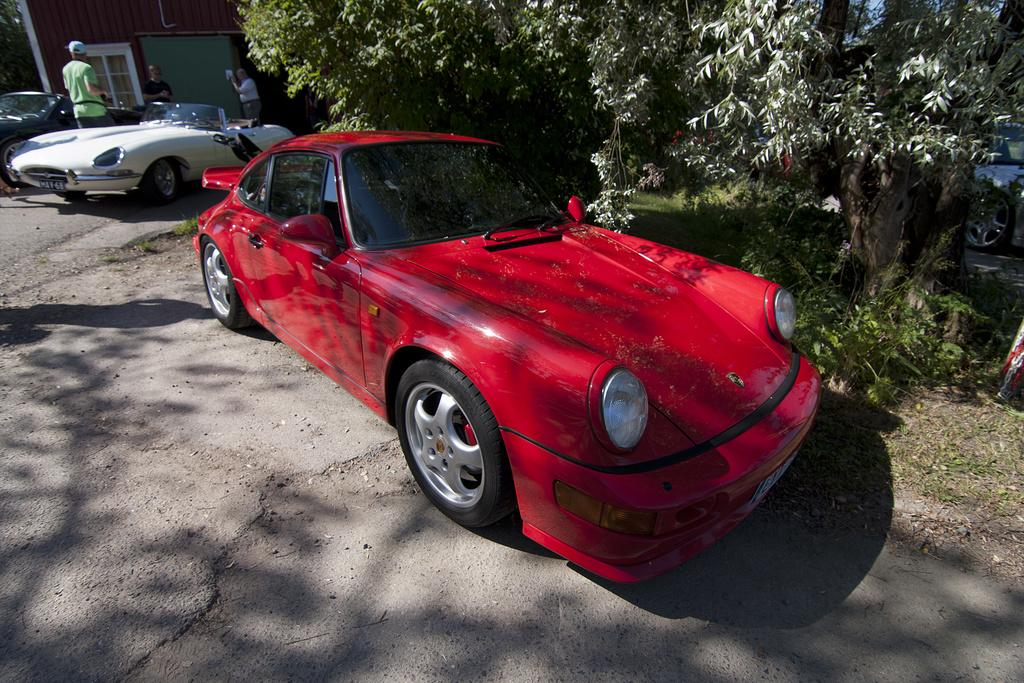What is the main structure in the image? There is a building in the image. What is happening in front of the building? There are people standing in front of the building. What are the people standing beside? The people are beside cars. What color is one of the cars in the image? There is a red car in the image. What type of vegetation is beside the red car? There are trees beside the red car. Can you tell me how many robins are perched on the trees beside the red car? There are no robins present in the image; only trees are visible beside the red car. Is there a boy standing beside the red car in the image? There is no boy visible beside the red car in the image; only people in general are mentioned. 